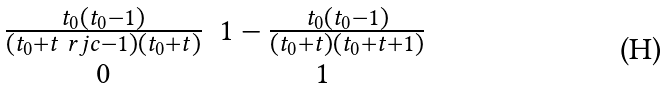Convert formula to latex. <formula><loc_0><loc_0><loc_500><loc_500>\begin{matrix} \frac { t _ { 0 } ( t _ { 0 } - 1 ) } { ( t _ { 0 } + t \ r j c { - 1 } ) ( t _ { 0 } + t ) } & 1 - \frac { t _ { 0 } ( t _ { 0 } - 1 ) } { ( t _ { 0 } + t ) ( t _ { 0 } + t + 1 ) } \\ 0 & 1 \end{matrix}</formula> 